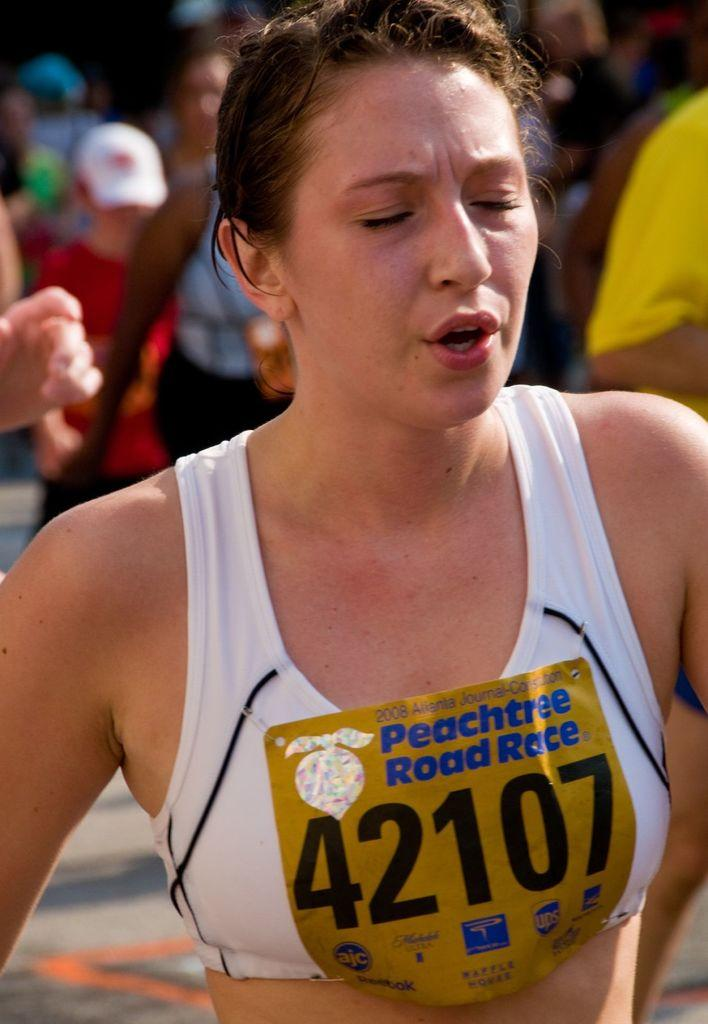<image>
Describe the image concisely. A runner wearing a banner that says Peachtree Road Race. 